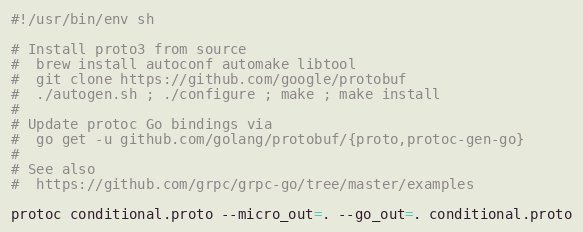Convert code to text. <code><loc_0><loc_0><loc_500><loc_500><_Bash_>#!/usr/bin/env sh

# Install proto3 from source
#  brew install autoconf automake libtool
#  git clone https://github.com/google/protobuf
#  ./autogen.sh ; ./configure ; make ; make install
#
# Update protoc Go bindings via
#  go get -u github.com/golang/protobuf/{proto,protoc-gen-go}
#
# See also
#  https://github.com/grpc/grpc-go/tree/master/examples

protoc conditional.proto --micro_out=. --go_out=. conditional.proto
</code> 